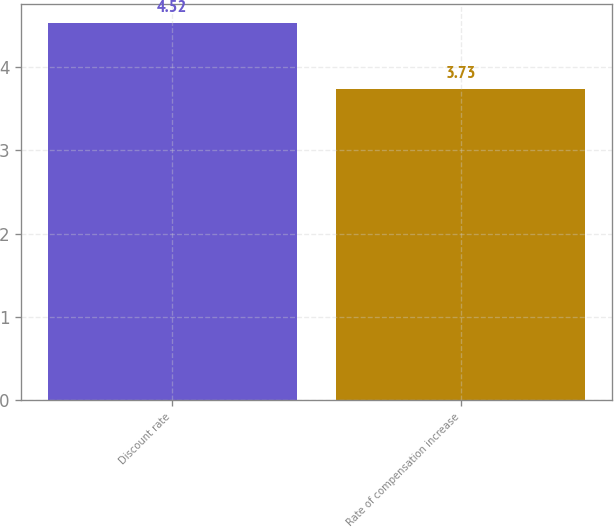Convert chart. <chart><loc_0><loc_0><loc_500><loc_500><bar_chart><fcel>Discount rate<fcel>Rate of compensation increase<nl><fcel>4.52<fcel>3.73<nl></chart> 